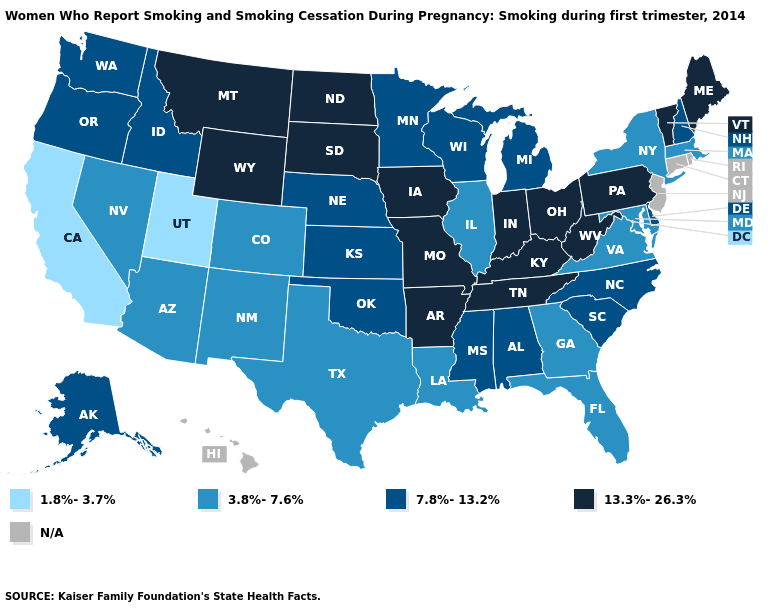What is the value of Texas?
Concise answer only. 3.8%-7.6%. Which states have the lowest value in the USA?
Answer briefly. California, Utah. Does California have the lowest value in the USA?
Be succinct. Yes. What is the highest value in the USA?
Be succinct. 13.3%-26.3%. What is the value of Nevada?
Answer briefly. 3.8%-7.6%. Name the states that have a value in the range 1.8%-3.7%?
Answer briefly. California, Utah. What is the value of South Carolina?
Be succinct. 7.8%-13.2%. Does Utah have the lowest value in the West?
Concise answer only. Yes. What is the value of New Hampshire?
Concise answer only. 7.8%-13.2%. Is the legend a continuous bar?
Give a very brief answer. No. Is the legend a continuous bar?
Quick response, please. No. Is the legend a continuous bar?
Write a very short answer. No. What is the lowest value in states that border New Mexico?
Quick response, please. 1.8%-3.7%. 